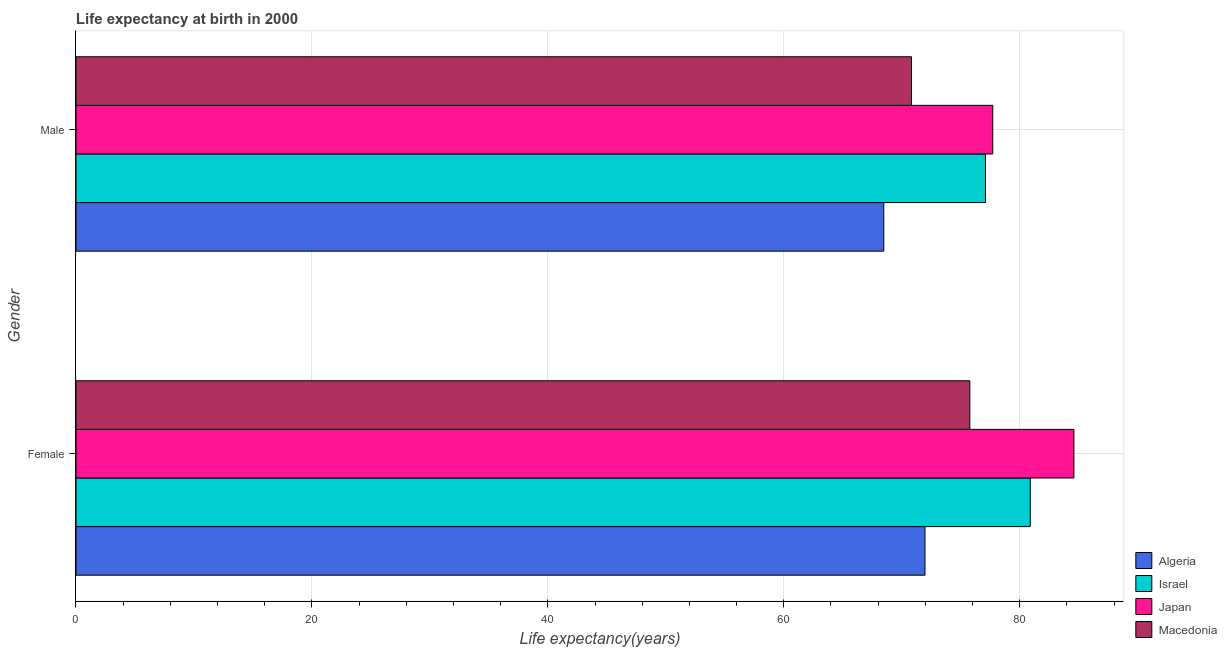How many different coloured bars are there?
Provide a succinct answer. 4. Are the number of bars on each tick of the Y-axis equal?
Your answer should be very brief. Yes. What is the life expectancy(male) in Japan?
Make the answer very short. 77.72. Across all countries, what is the maximum life expectancy(male)?
Your response must be concise. 77.72. Across all countries, what is the minimum life expectancy(female)?
Give a very brief answer. 71.97. In which country was the life expectancy(male) minimum?
Offer a very short reply. Algeria. What is the total life expectancy(male) in the graph?
Provide a short and direct response. 294.13. What is the difference between the life expectancy(male) in Israel and that in Macedonia?
Ensure brevity in your answer.  6.27. What is the difference between the life expectancy(female) in Macedonia and the life expectancy(male) in Japan?
Give a very brief answer. -1.94. What is the average life expectancy(female) per country?
Your answer should be compact. 78.31. What is the difference between the life expectancy(female) and life expectancy(male) in Japan?
Your answer should be compact. 6.88. What is the ratio of the life expectancy(female) in Japan to that in Algeria?
Your answer should be very brief. 1.18. Is the life expectancy(female) in Macedonia less than that in Algeria?
Provide a short and direct response. No. In how many countries, is the life expectancy(male) greater than the average life expectancy(male) taken over all countries?
Ensure brevity in your answer.  2. What does the 4th bar from the top in Male represents?
Your response must be concise. Algeria. How many countries are there in the graph?
Offer a very short reply. 4. What is the difference between two consecutive major ticks on the X-axis?
Give a very brief answer. 20. Does the graph contain any zero values?
Your answer should be very brief. No. How many legend labels are there?
Offer a very short reply. 4. What is the title of the graph?
Give a very brief answer. Life expectancy at birth in 2000. Does "Northern Mariana Islands" appear as one of the legend labels in the graph?
Offer a terse response. No. What is the label or title of the X-axis?
Offer a very short reply. Life expectancy(years). What is the label or title of the Y-axis?
Offer a terse response. Gender. What is the Life expectancy(years) of Algeria in Female?
Your response must be concise. 71.97. What is the Life expectancy(years) in Israel in Female?
Your response must be concise. 80.9. What is the Life expectancy(years) of Japan in Female?
Offer a terse response. 84.6. What is the Life expectancy(years) in Macedonia in Female?
Offer a terse response. 75.78. What is the Life expectancy(years) in Algeria in Male?
Keep it short and to the point. 68.48. What is the Life expectancy(years) of Israel in Male?
Make the answer very short. 77.1. What is the Life expectancy(years) of Japan in Male?
Provide a short and direct response. 77.72. What is the Life expectancy(years) in Macedonia in Male?
Give a very brief answer. 70.83. Across all Gender, what is the maximum Life expectancy(years) of Algeria?
Offer a very short reply. 71.97. Across all Gender, what is the maximum Life expectancy(years) in Israel?
Your answer should be very brief. 80.9. Across all Gender, what is the maximum Life expectancy(years) of Japan?
Provide a succinct answer. 84.6. Across all Gender, what is the maximum Life expectancy(years) in Macedonia?
Your response must be concise. 75.78. Across all Gender, what is the minimum Life expectancy(years) of Algeria?
Provide a succinct answer. 68.48. Across all Gender, what is the minimum Life expectancy(years) in Israel?
Provide a succinct answer. 77.1. Across all Gender, what is the minimum Life expectancy(years) in Japan?
Your response must be concise. 77.72. Across all Gender, what is the minimum Life expectancy(years) in Macedonia?
Your answer should be very brief. 70.83. What is the total Life expectancy(years) in Algeria in the graph?
Give a very brief answer. 140.45. What is the total Life expectancy(years) in Israel in the graph?
Offer a very short reply. 158. What is the total Life expectancy(years) in Japan in the graph?
Your answer should be very brief. 162.32. What is the total Life expectancy(years) of Macedonia in the graph?
Your answer should be compact. 146.6. What is the difference between the Life expectancy(years) of Algeria in Female and that in Male?
Your response must be concise. 3.49. What is the difference between the Life expectancy(years) in Japan in Female and that in Male?
Ensure brevity in your answer.  6.88. What is the difference between the Life expectancy(years) of Macedonia in Female and that in Male?
Provide a succinct answer. 4.95. What is the difference between the Life expectancy(years) in Algeria in Female and the Life expectancy(years) in Israel in Male?
Make the answer very short. -5.13. What is the difference between the Life expectancy(years) of Algeria in Female and the Life expectancy(years) of Japan in Male?
Your answer should be very brief. -5.75. What is the difference between the Life expectancy(years) of Algeria in Female and the Life expectancy(years) of Macedonia in Male?
Ensure brevity in your answer.  1.14. What is the difference between the Life expectancy(years) in Israel in Female and the Life expectancy(years) in Japan in Male?
Offer a terse response. 3.18. What is the difference between the Life expectancy(years) of Israel in Female and the Life expectancy(years) of Macedonia in Male?
Keep it short and to the point. 10.07. What is the difference between the Life expectancy(years) in Japan in Female and the Life expectancy(years) in Macedonia in Male?
Your answer should be very brief. 13.77. What is the average Life expectancy(years) of Algeria per Gender?
Make the answer very short. 70.23. What is the average Life expectancy(years) of Israel per Gender?
Provide a succinct answer. 79. What is the average Life expectancy(years) in Japan per Gender?
Provide a succinct answer. 81.16. What is the average Life expectancy(years) of Macedonia per Gender?
Make the answer very short. 73.3. What is the difference between the Life expectancy(years) in Algeria and Life expectancy(years) in Israel in Female?
Your answer should be compact. -8.93. What is the difference between the Life expectancy(years) of Algeria and Life expectancy(years) of Japan in Female?
Your response must be concise. -12.63. What is the difference between the Life expectancy(years) of Algeria and Life expectancy(years) of Macedonia in Female?
Offer a terse response. -3.8. What is the difference between the Life expectancy(years) of Israel and Life expectancy(years) of Japan in Female?
Your response must be concise. -3.7. What is the difference between the Life expectancy(years) in Israel and Life expectancy(years) in Macedonia in Female?
Make the answer very short. 5.12. What is the difference between the Life expectancy(years) in Japan and Life expectancy(years) in Macedonia in Female?
Offer a very short reply. 8.82. What is the difference between the Life expectancy(years) in Algeria and Life expectancy(years) in Israel in Male?
Provide a short and direct response. -8.62. What is the difference between the Life expectancy(years) of Algeria and Life expectancy(years) of Japan in Male?
Provide a short and direct response. -9.24. What is the difference between the Life expectancy(years) of Algeria and Life expectancy(years) of Macedonia in Male?
Keep it short and to the point. -2.35. What is the difference between the Life expectancy(years) of Israel and Life expectancy(years) of Japan in Male?
Give a very brief answer. -0.62. What is the difference between the Life expectancy(years) of Israel and Life expectancy(years) of Macedonia in Male?
Provide a short and direct response. 6.27. What is the difference between the Life expectancy(years) of Japan and Life expectancy(years) of Macedonia in Male?
Provide a succinct answer. 6.89. What is the ratio of the Life expectancy(years) in Algeria in Female to that in Male?
Make the answer very short. 1.05. What is the ratio of the Life expectancy(years) in Israel in Female to that in Male?
Ensure brevity in your answer.  1.05. What is the ratio of the Life expectancy(years) of Japan in Female to that in Male?
Your answer should be compact. 1.09. What is the ratio of the Life expectancy(years) in Macedonia in Female to that in Male?
Your answer should be compact. 1.07. What is the difference between the highest and the second highest Life expectancy(years) of Algeria?
Provide a short and direct response. 3.49. What is the difference between the highest and the second highest Life expectancy(years) in Japan?
Offer a terse response. 6.88. What is the difference between the highest and the second highest Life expectancy(years) in Macedonia?
Provide a succinct answer. 4.95. What is the difference between the highest and the lowest Life expectancy(years) in Algeria?
Your answer should be compact. 3.49. What is the difference between the highest and the lowest Life expectancy(years) of Japan?
Give a very brief answer. 6.88. What is the difference between the highest and the lowest Life expectancy(years) in Macedonia?
Offer a terse response. 4.95. 